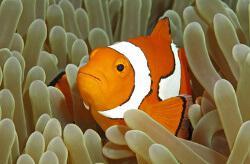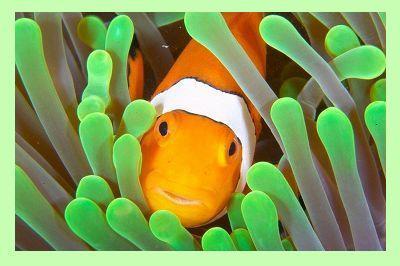The first image is the image on the left, the second image is the image on the right. Considering the images on both sides, is "At least one image has more than one clown fish." valid? Answer yes or no. No. 